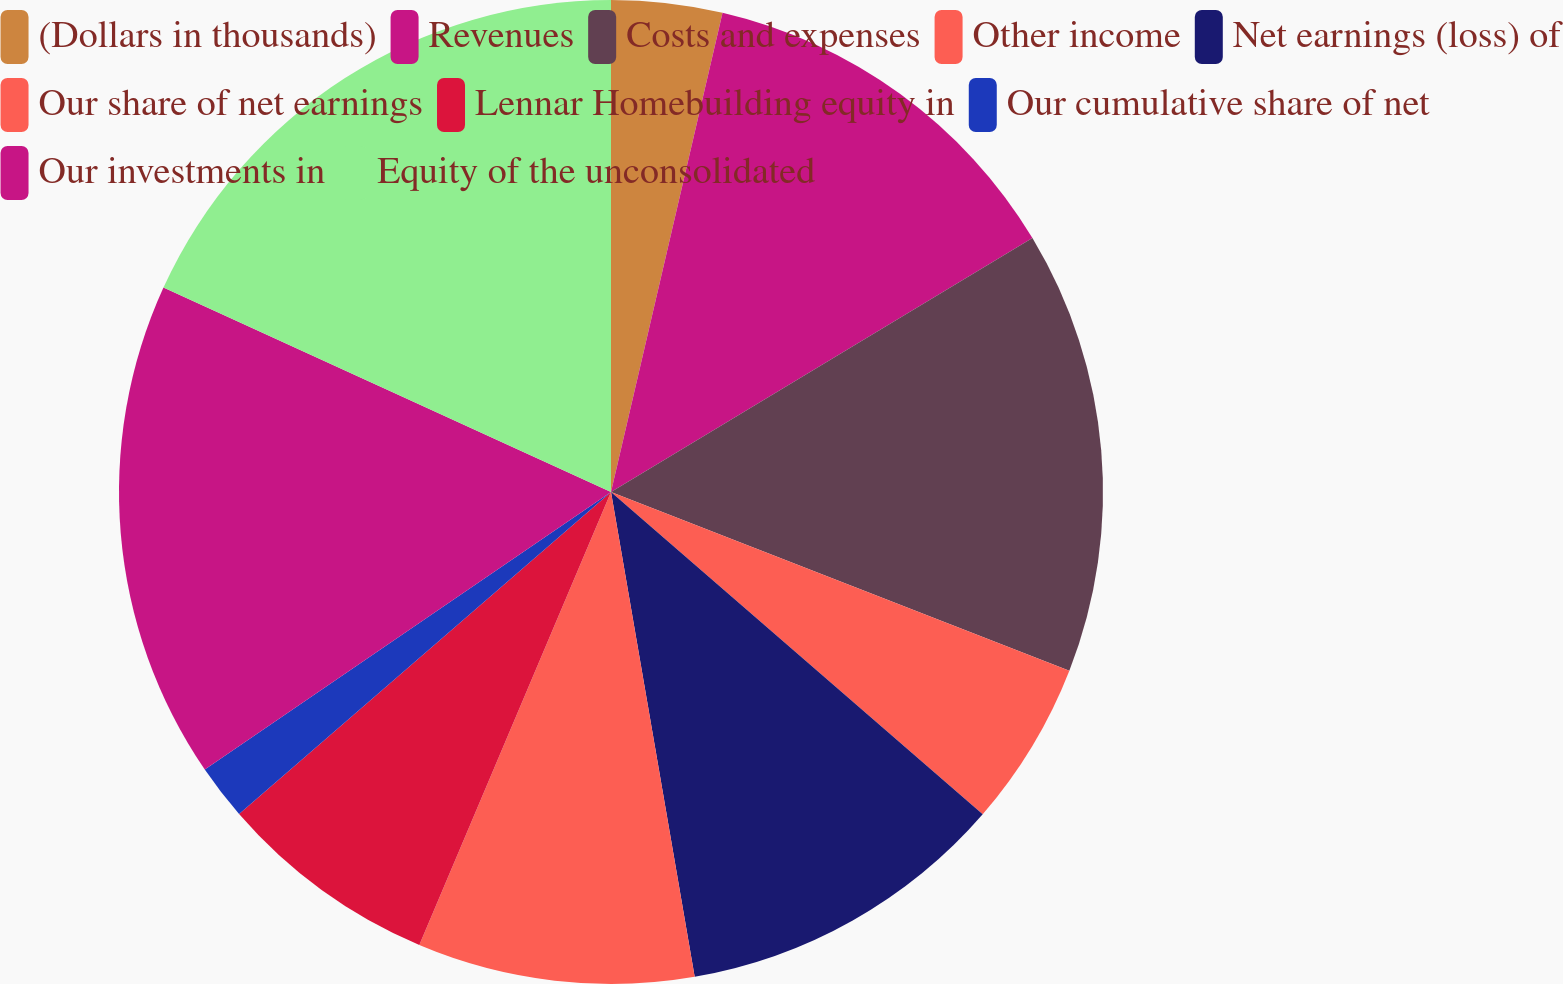<chart> <loc_0><loc_0><loc_500><loc_500><pie_chart><fcel>(Dollars in thousands)<fcel>Revenues<fcel>Costs and expenses<fcel>Other income<fcel>Net earnings (loss) of<fcel>Our share of net earnings<fcel>Lennar Homebuilding equity in<fcel>Our cumulative share of net<fcel>Our investments in<fcel>Equity of the unconsolidated<nl><fcel>3.64%<fcel>12.73%<fcel>14.55%<fcel>5.45%<fcel>10.91%<fcel>9.09%<fcel>7.27%<fcel>1.82%<fcel>16.36%<fcel>18.18%<nl></chart> 